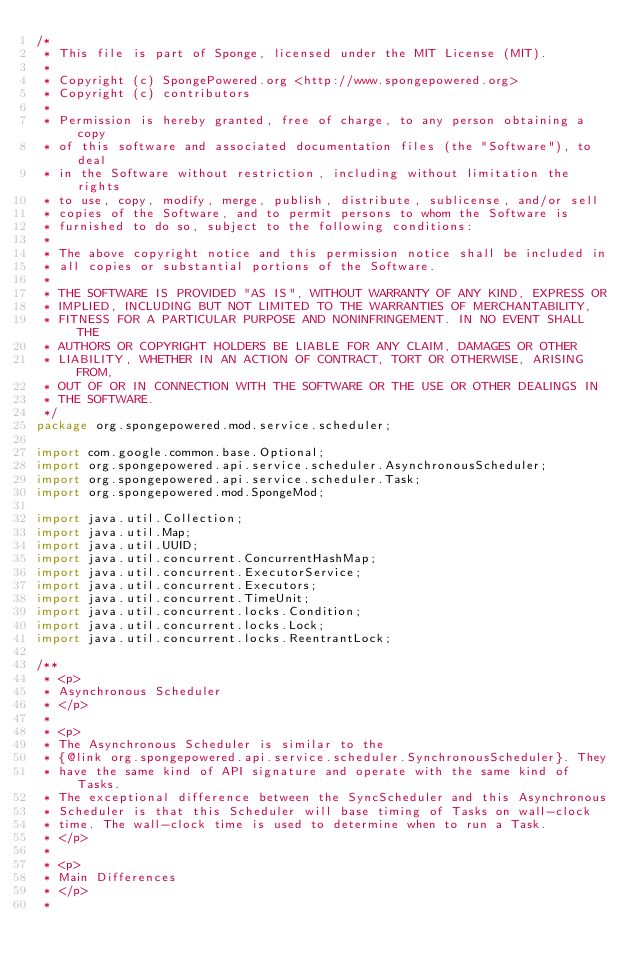<code> <loc_0><loc_0><loc_500><loc_500><_Java_>/*
 * This file is part of Sponge, licensed under the MIT License (MIT).
 *
 * Copyright (c) SpongePowered.org <http://www.spongepowered.org>
 * Copyright (c) contributors
 *
 * Permission is hereby granted, free of charge, to any person obtaining a copy
 * of this software and associated documentation files (the "Software"), to deal
 * in the Software without restriction, including without limitation the rights
 * to use, copy, modify, merge, publish, distribute, sublicense, and/or sell
 * copies of the Software, and to permit persons to whom the Software is
 * furnished to do so, subject to the following conditions:
 *
 * The above copyright notice and this permission notice shall be included in
 * all copies or substantial portions of the Software.
 *
 * THE SOFTWARE IS PROVIDED "AS IS", WITHOUT WARRANTY OF ANY KIND, EXPRESS OR
 * IMPLIED, INCLUDING BUT NOT LIMITED TO THE WARRANTIES OF MERCHANTABILITY,
 * FITNESS FOR A PARTICULAR PURPOSE AND NONINFRINGEMENT. IN NO EVENT SHALL THE
 * AUTHORS OR COPYRIGHT HOLDERS BE LIABLE FOR ANY CLAIM, DAMAGES OR OTHER
 * LIABILITY, WHETHER IN AN ACTION OF CONTRACT, TORT OR OTHERWISE, ARISING FROM,
 * OUT OF OR IN CONNECTION WITH THE SOFTWARE OR THE USE OR OTHER DEALINGS IN
 * THE SOFTWARE.
 */
package org.spongepowered.mod.service.scheduler;

import com.google.common.base.Optional;
import org.spongepowered.api.service.scheduler.AsynchronousScheduler;
import org.spongepowered.api.service.scheduler.Task;
import org.spongepowered.mod.SpongeMod;

import java.util.Collection;
import java.util.Map;
import java.util.UUID;
import java.util.concurrent.ConcurrentHashMap;
import java.util.concurrent.ExecutorService;
import java.util.concurrent.Executors;
import java.util.concurrent.TimeUnit;
import java.util.concurrent.locks.Condition;
import java.util.concurrent.locks.Lock;
import java.util.concurrent.locks.ReentrantLock;

/**
 * <p>
 * Asynchronous Scheduler
 * </p>
 *
 * <p>
 * The Asynchronous Scheduler is similar to the
 * {@link org.spongepowered.api.service.scheduler.SynchronousScheduler}. They
 * have the same kind of API signature and operate with the same kind of Tasks.
 * The exceptional difference between the SyncScheduler and this Asynchronous
 * Scheduler is that this Scheduler will base timing of Tasks on wall-clock
 * time. The wall-clock time is used to determine when to run a Task.
 * </p>
 *
 * <p>
 * Main Differences
 * </p>
 *</code> 